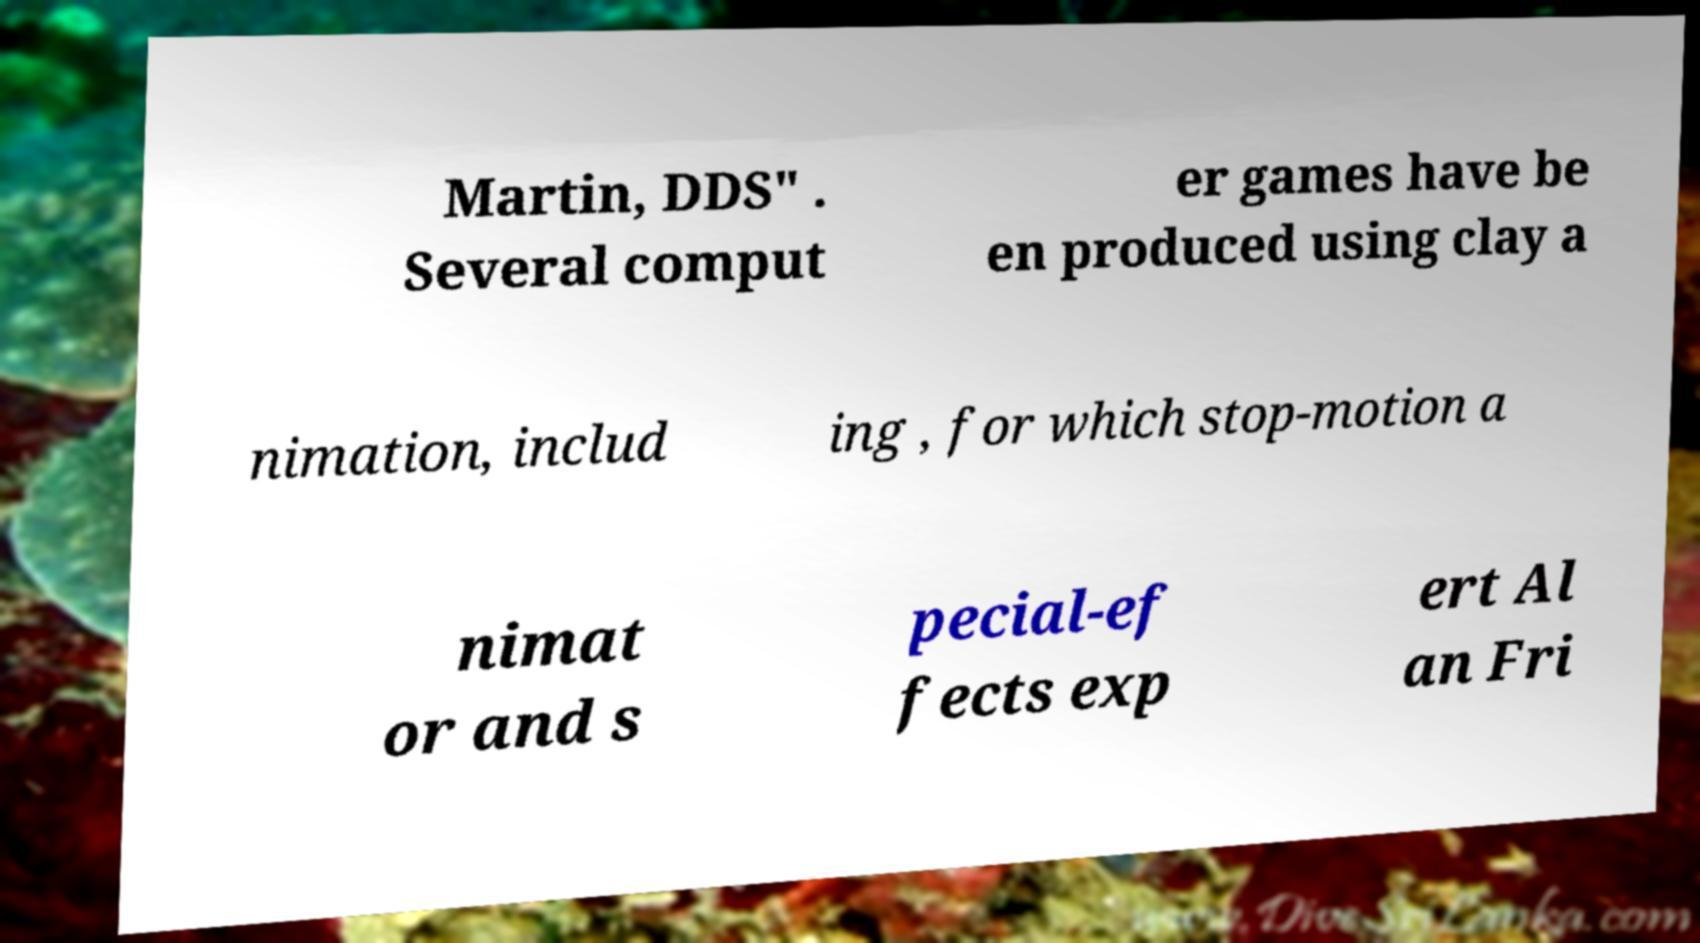There's text embedded in this image that I need extracted. Can you transcribe it verbatim? Martin, DDS" . Several comput er games have be en produced using clay a nimation, includ ing , for which stop-motion a nimat or and s pecial-ef fects exp ert Al an Fri 